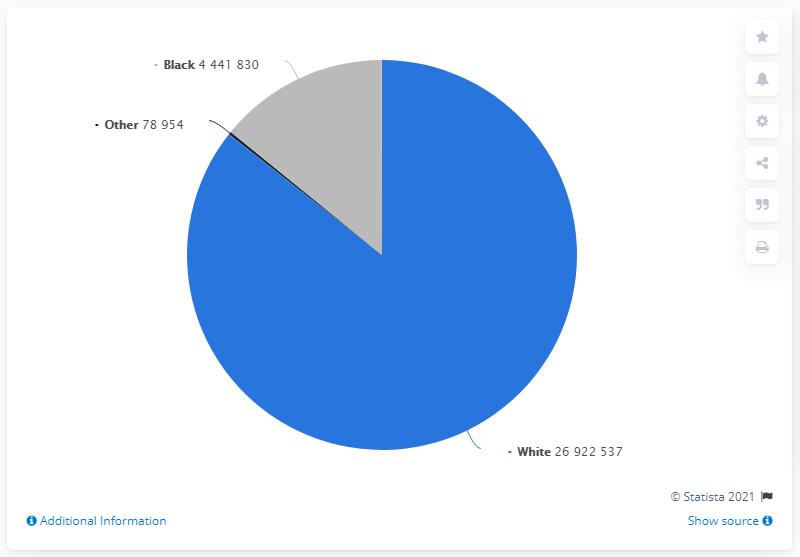Point out several critical features in this image. The chart depicts a population of 78,954 individuals. In the year 1860, approximately 269,225,370 white people lived in the United States. There are a total of three colored segments. 